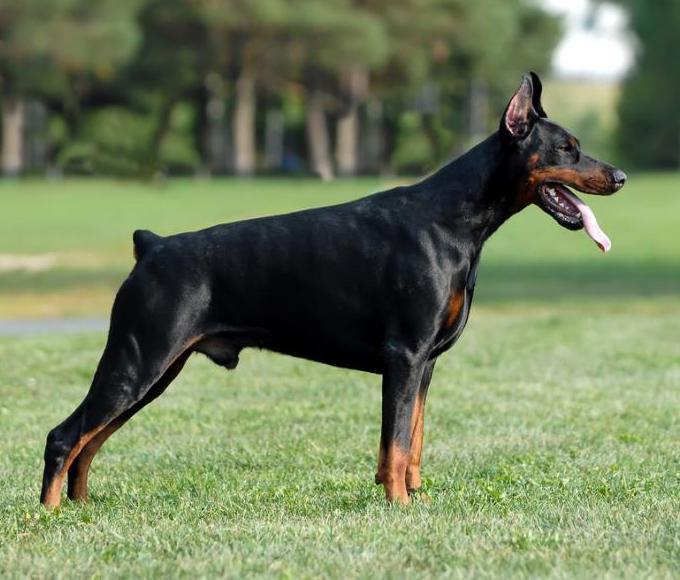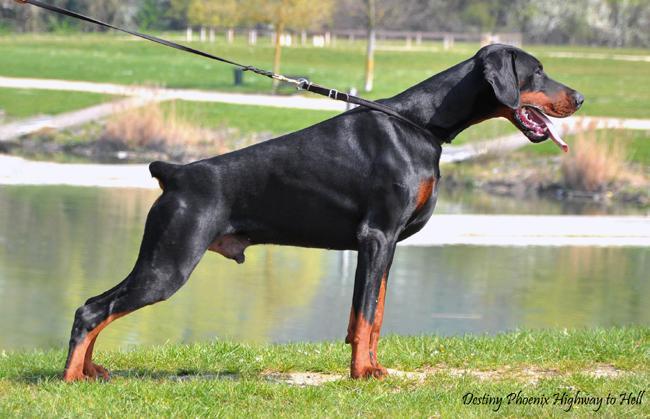The first image is the image on the left, the second image is the image on the right. Examine the images to the left and right. Is the description "The left image shows a floppy-eared doberman standing with its undocked tail curled upward, and the right image shows a doberman with pointy erect ears and a docked tail who is standing up." accurate? Answer yes or no. No. The first image is the image on the left, the second image is the image on the right. Given the left and right images, does the statement "One dog's tail is docked; the other dog's tail is normal." hold true? Answer yes or no. No. 